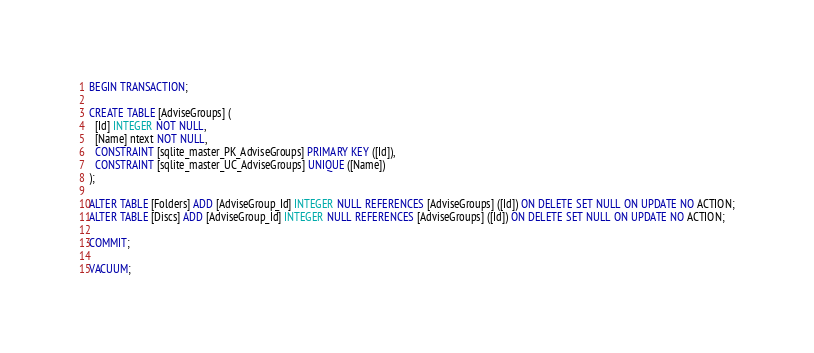Convert code to text. <code><loc_0><loc_0><loc_500><loc_500><_SQL_>BEGIN TRANSACTION;

CREATE TABLE [AdviseGroups] (
  [Id] INTEGER NOT NULL,
  [Name] ntext NOT NULL,
  CONSTRAINT [sqlite_master_PK_AdviseGroups] PRIMARY KEY ([Id]),
  CONSTRAINT [sqlite_master_UC_AdviseGroups] UNIQUE ([Name])
);

ALTER TABLE [Folders] ADD [AdviseGroup_Id] INTEGER NULL REFERENCES [AdviseGroups] ([Id]) ON DELETE SET NULL ON UPDATE NO ACTION;
ALTER TABLE [Discs] ADD [AdviseGroup_Id] INTEGER NULL REFERENCES [AdviseGroups] ([Id]) ON DELETE SET NULL ON UPDATE NO ACTION;

COMMIT;

VACUUM;
</code> 